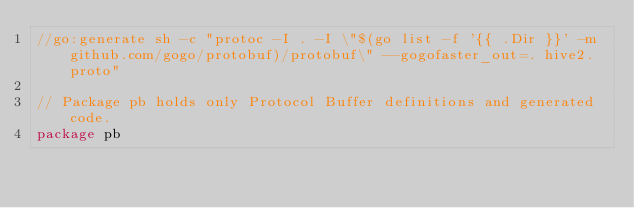Convert code to text. <code><loc_0><loc_0><loc_500><loc_500><_Go_>//go:generate sh -c "protoc -I . -I \"$(go list -f '{{ .Dir }}' -m github.com/gogo/protobuf)/protobuf\" --gogofaster_out=. hive2.proto"

// Package pb holds only Protocol Buffer definitions and generated code.
package pb
</code> 